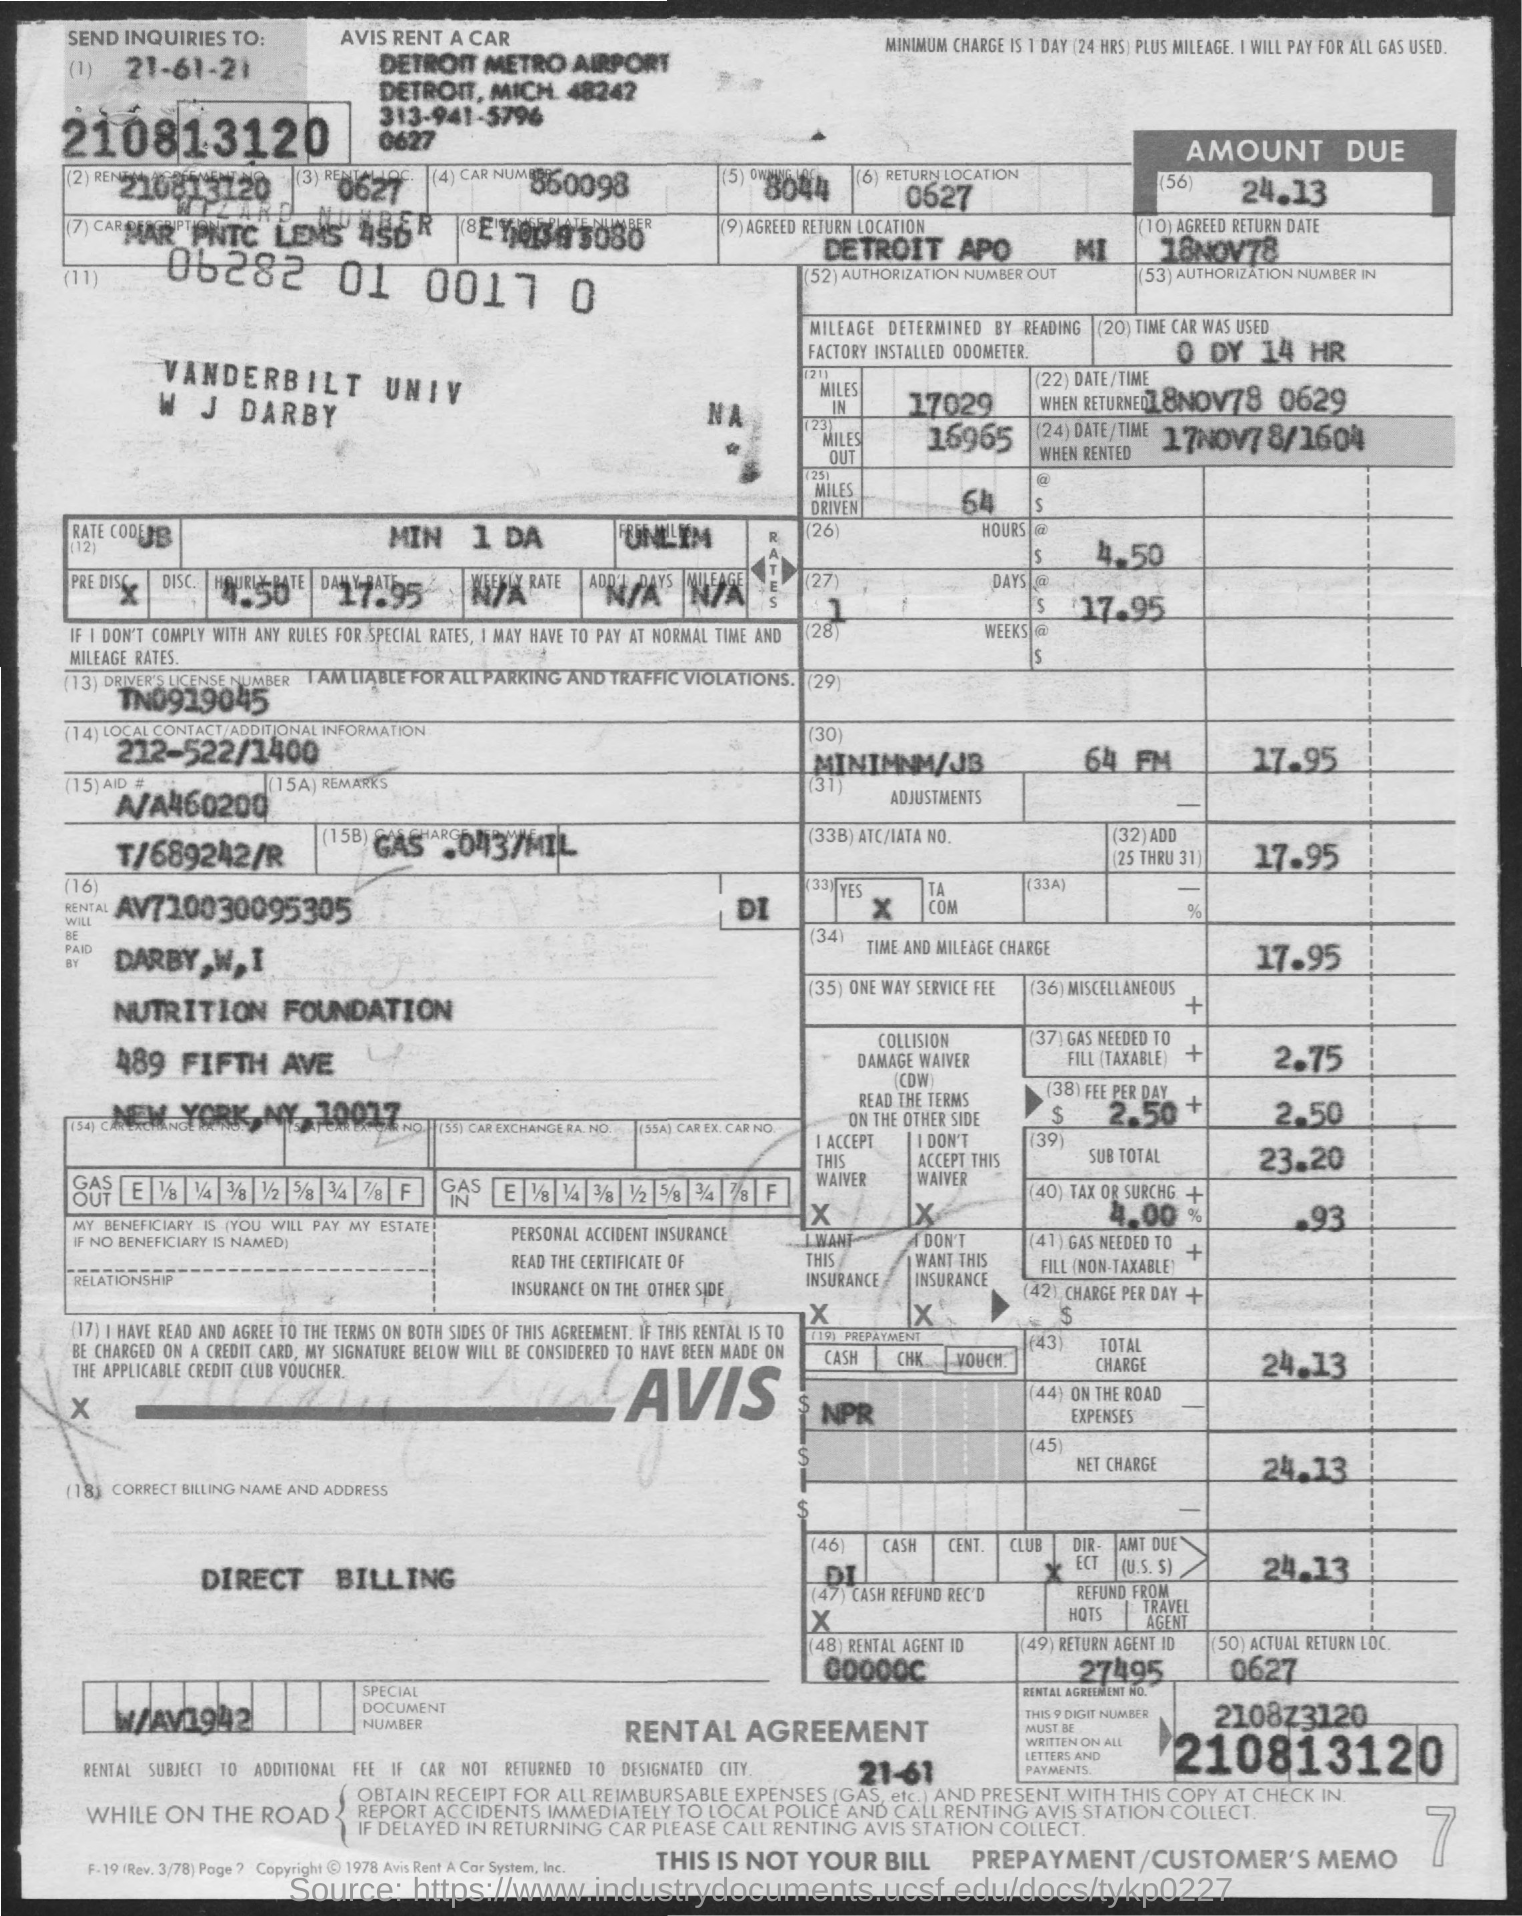Highlight a few significant elements in this photo. According to the given form, the car was used for 14 hours. What is the car number mentioned in the provided form? 860098... The number of miles driven is 64, as mentioned in the given form. There are 16,965 miles mentioned in the given form. The number of miles mentioned in the given form is 17029. 